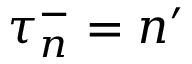<formula> <loc_0><loc_0><loc_500><loc_500>\tau _ { n } ^ { - } = n ^ { \prime }</formula> 